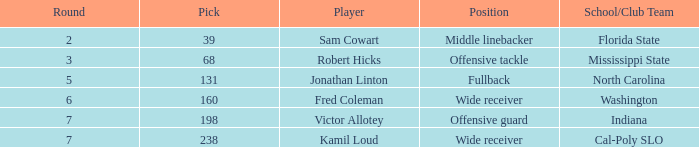In which round can a cal poly slo school/club team be found with a pick number smaller than 238? None. 